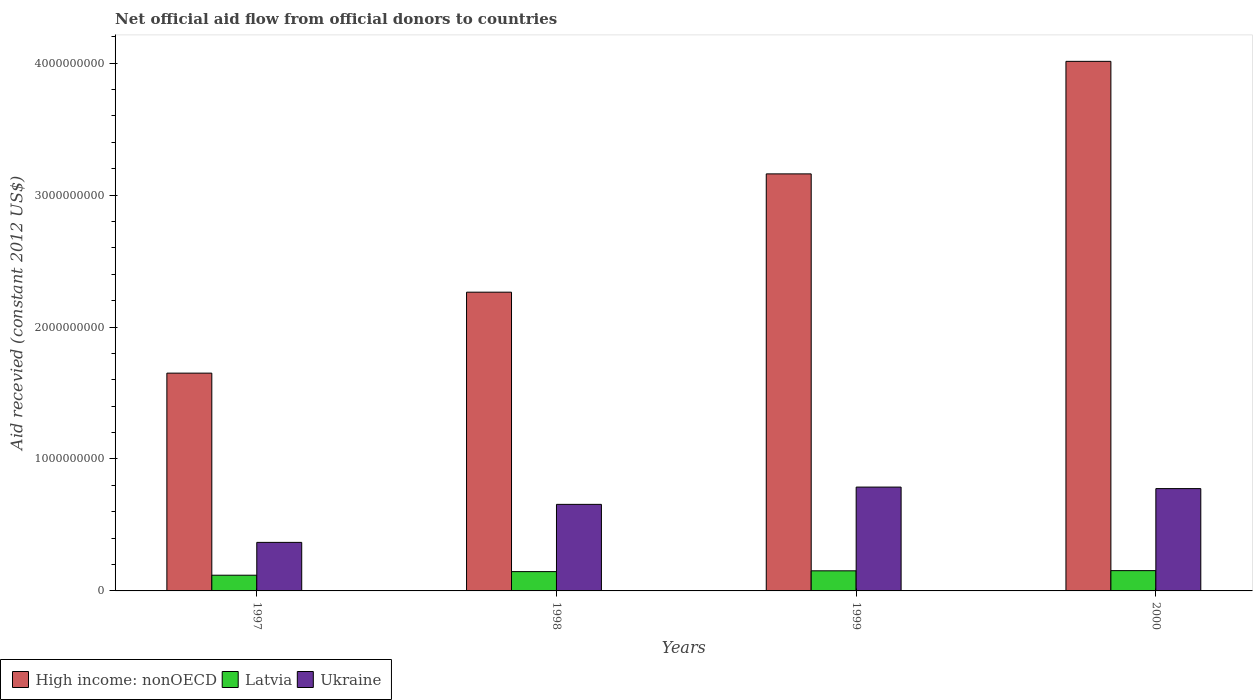How many bars are there on the 1st tick from the right?
Offer a very short reply. 3. In how many cases, is the number of bars for a given year not equal to the number of legend labels?
Keep it short and to the point. 0. What is the total aid received in High income: nonOECD in 1997?
Keep it short and to the point. 1.65e+09. Across all years, what is the maximum total aid received in Ukraine?
Your answer should be compact. 7.87e+08. Across all years, what is the minimum total aid received in High income: nonOECD?
Provide a succinct answer. 1.65e+09. In which year was the total aid received in Ukraine minimum?
Provide a short and direct response. 1997. What is the total total aid received in Latvia in the graph?
Your answer should be very brief. 5.72e+08. What is the difference between the total aid received in High income: nonOECD in 1997 and that in 2000?
Provide a succinct answer. -2.36e+09. What is the difference between the total aid received in High income: nonOECD in 1997 and the total aid received in Ukraine in 1999?
Your answer should be very brief. 8.64e+08. What is the average total aid received in Latvia per year?
Keep it short and to the point. 1.43e+08. In the year 1997, what is the difference between the total aid received in Latvia and total aid received in Ukraine?
Make the answer very short. -2.49e+08. What is the ratio of the total aid received in High income: nonOECD in 1998 to that in 1999?
Your answer should be compact. 0.72. Is the difference between the total aid received in Latvia in 1998 and 1999 greater than the difference between the total aid received in Ukraine in 1998 and 1999?
Your answer should be very brief. Yes. What is the difference between the highest and the second highest total aid received in Ukraine?
Provide a succinct answer. 1.14e+07. What is the difference between the highest and the lowest total aid received in Latvia?
Give a very brief answer. 3.48e+07. In how many years, is the total aid received in High income: nonOECD greater than the average total aid received in High income: nonOECD taken over all years?
Give a very brief answer. 2. What does the 2nd bar from the left in 2000 represents?
Keep it short and to the point. Latvia. What does the 3rd bar from the right in 1997 represents?
Offer a terse response. High income: nonOECD. Is it the case that in every year, the sum of the total aid received in Latvia and total aid received in High income: nonOECD is greater than the total aid received in Ukraine?
Give a very brief answer. Yes. How many bars are there?
Your response must be concise. 12. How many years are there in the graph?
Offer a terse response. 4. Are the values on the major ticks of Y-axis written in scientific E-notation?
Provide a short and direct response. No. Does the graph contain grids?
Your answer should be very brief. No. Where does the legend appear in the graph?
Offer a terse response. Bottom left. How many legend labels are there?
Give a very brief answer. 3. What is the title of the graph?
Ensure brevity in your answer.  Net official aid flow from official donors to countries. Does "Benin" appear as one of the legend labels in the graph?
Offer a very short reply. No. What is the label or title of the X-axis?
Make the answer very short. Years. What is the label or title of the Y-axis?
Make the answer very short. Aid recevied (constant 2012 US$). What is the Aid recevied (constant 2012 US$) of High income: nonOECD in 1997?
Offer a very short reply. 1.65e+09. What is the Aid recevied (constant 2012 US$) of Latvia in 1997?
Offer a terse response. 1.19e+08. What is the Aid recevied (constant 2012 US$) in Ukraine in 1997?
Keep it short and to the point. 3.68e+08. What is the Aid recevied (constant 2012 US$) in High income: nonOECD in 1998?
Your response must be concise. 2.26e+09. What is the Aid recevied (constant 2012 US$) of Latvia in 1998?
Offer a very short reply. 1.46e+08. What is the Aid recevied (constant 2012 US$) in Ukraine in 1998?
Ensure brevity in your answer.  6.56e+08. What is the Aid recevied (constant 2012 US$) in High income: nonOECD in 1999?
Provide a succinct answer. 3.16e+09. What is the Aid recevied (constant 2012 US$) of Latvia in 1999?
Give a very brief answer. 1.52e+08. What is the Aid recevied (constant 2012 US$) in Ukraine in 1999?
Your response must be concise. 7.87e+08. What is the Aid recevied (constant 2012 US$) of High income: nonOECD in 2000?
Keep it short and to the point. 4.01e+09. What is the Aid recevied (constant 2012 US$) in Latvia in 2000?
Make the answer very short. 1.54e+08. What is the Aid recevied (constant 2012 US$) in Ukraine in 2000?
Ensure brevity in your answer.  7.75e+08. Across all years, what is the maximum Aid recevied (constant 2012 US$) in High income: nonOECD?
Your answer should be very brief. 4.01e+09. Across all years, what is the maximum Aid recevied (constant 2012 US$) in Latvia?
Offer a terse response. 1.54e+08. Across all years, what is the maximum Aid recevied (constant 2012 US$) in Ukraine?
Make the answer very short. 7.87e+08. Across all years, what is the minimum Aid recevied (constant 2012 US$) of High income: nonOECD?
Provide a short and direct response. 1.65e+09. Across all years, what is the minimum Aid recevied (constant 2012 US$) of Latvia?
Your answer should be compact. 1.19e+08. Across all years, what is the minimum Aid recevied (constant 2012 US$) in Ukraine?
Your answer should be compact. 3.68e+08. What is the total Aid recevied (constant 2012 US$) in High income: nonOECD in the graph?
Give a very brief answer. 1.11e+1. What is the total Aid recevied (constant 2012 US$) of Latvia in the graph?
Offer a very short reply. 5.72e+08. What is the total Aid recevied (constant 2012 US$) in Ukraine in the graph?
Give a very brief answer. 2.59e+09. What is the difference between the Aid recevied (constant 2012 US$) of High income: nonOECD in 1997 and that in 1998?
Keep it short and to the point. -6.13e+08. What is the difference between the Aid recevied (constant 2012 US$) in Latvia in 1997 and that in 1998?
Your answer should be very brief. -2.73e+07. What is the difference between the Aid recevied (constant 2012 US$) in Ukraine in 1997 and that in 1998?
Keep it short and to the point. -2.88e+08. What is the difference between the Aid recevied (constant 2012 US$) in High income: nonOECD in 1997 and that in 1999?
Offer a terse response. -1.51e+09. What is the difference between the Aid recevied (constant 2012 US$) in Latvia in 1997 and that in 1999?
Your response must be concise. -3.33e+07. What is the difference between the Aid recevied (constant 2012 US$) of Ukraine in 1997 and that in 1999?
Your answer should be very brief. -4.19e+08. What is the difference between the Aid recevied (constant 2012 US$) of High income: nonOECD in 1997 and that in 2000?
Keep it short and to the point. -2.36e+09. What is the difference between the Aid recevied (constant 2012 US$) of Latvia in 1997 and that in 2000?
Ensure brevity in your answer.  -3.48e+07. What is the difference between the Aid recevied (constant 2012 US$) of Ukraine in 1997 and that in 2000?
Provide a succinct answer. -4.08e+08. What is the difference between the Aid recevied (constant 2012 US$) of High income: nonOECD in 1998 and that in 1999?
Give a very brief answer. -8.97e+08. What is the difference between the Aid recevied (constant 2012 US$) in Latvia in 1998 and that in 1999?
Your answer should be very brief. -5.96e+06. What is the difference between the Aid recevied (constant 2012 US$) of Ukraine in 1998 and that in 1999?
Keep it short and to the point. -1.31e+08. What is the difference between the Aid recevied (constant 2012 US$) in High income: nonOECD in 1998 and that in 2000?
Provide a succinct answer. -1.75e+09. What is the difference between the Aid recevied (constant 2012 US$) of Latvia in 1998 and that in 2000?
Provide a short and direct response. -7.46e+06. What is the difference between the Aid recevied (constant 2012 US$) in Ukraine in 1998 and that in 2000?
Keep it short and to the point. -1.19e+08. What is the difference between the Aid recevied (constant 2012 US$) in High income: nonOECD in 1999 and that in 2000?
Make the answer very short. -8.53e+08. What is the difference between the Aid recevied (constant 2012 US$) in Latvia in 1999 and that in 2000?
Your answer should be compact. -1.50e+06. What is the difference between the Aid recevied (constant 2012 US$) in Ukraine in 1999 and that in 2000?
Offer a very short reply. 1.14e+07. What is the difference between the Aid recevied (constant 2012 US$) of High income: nonOECD in 1997 and the Aid recevied (constant 2012 US$) of Latvia in 1998?
Your response must be concise. 1.50e+09. What is the difference between the Aid recevied (constant 2012 US$) of High income: nonOECD in 1997 and the Aid recevied (constant 2012 US$) of Ukraine in 1998?
Make the answer very short. 9.95e+08. What is the difference between the Aid recevied (constant 2012 US$) in Latvia in 1997 and the Aid recevied (constant 2012 US$) in Ukraine in 1998?
Provide a succinct answer. -5.37e+08. What is the difference between the Aid recevied (constant 2012 US$) of High income: nonOECD in 1997 and the Aid recevied (constant 2012 US$) of Latvia in 1999?
Offer a very short reply. 1.50e+09. What is the difference between the Aid recevied (constant 2012 US$) of High income: nonOECD in 1997 and the Aid recevied (constant 2012 US$) of Ukraine in 1999?
Ensure brevity in your answer.  8.64e+08. What is the difference between the Aid recevied (constant 2012 US$) in Latvia in 1997 and the Aid recevied (constant 2012 US$) in Ukraine in 1999?
Ensure brevity in your answer.  -6.68e+08. What is the difference between the Aid recevied (constant 2012 US$) in High income: nonOECD in 1997 and the Aid recevied (constant 2012 US$) in Latvia in 2000?
Make the answer very short. 1.50e+09. What is the difference between the Aid recevied (constant 2012 US$) in High income: nonOECD in 1997 and the Aid recevied (constant 2012 US$) in Ukraine in 2000?
Offer a terse response. 8.75e+08. What is the difference between the Aid recevied (constant 2012 US$) in Latvia in 1997 and the Aid recevied (constant 2012 US$) in Ukraine in 2000?
Keep it short and to the point. -6.56e+08. What is the difference between the Aid recevied (constant 2012 US$) of High income: nonOECD in 1998 and the Aid recevied (constant 2012 US$) of Latvia in 1999?
Your response must be concise. 2.11e+09. What is the difference between the Aid recevied (constant 2012 US$) of High income: nonOECD in 1998 and the Aid recevied (constant 2012 US$) of Ukraine in 1999?
Make the answer very short. 1.48e+09. What is the difference between the Aid recevied (constant 2012 US$) of Latvia in 1998 and the Aid recevied (constant 2012 US$) of Ukraine in 1999?
Offer a terse response. -6.41e+08. What is the difference between the Aid recevied (constant 2012 US$) of High income: nonOECD in 1998 and the Aid recevied (constant 2012 US$) of Latvia in 2000?
Ensure brevity in your answer.  2.11e+09. What is the difference between the Aid recevied (constant 2012 US$) in High income: nonOECD in 1998 and the Aid recevied (constant 2012 US$) in Ukraine in 2000?
Offer a terse response. 1.49e+09. What is the difference between the Aid recevied (constant 2012 US$) in Latvia in 1998 and the Aid recevied (constant 2012 US$) in Ukraine in 2000?
Make the answer very short. -6.29e+08. What is the difference between the Aid recevied (constant 2012 US$) of High income: nonOECD in 1999 and the Aid recevied (constant 2012 US$) of Latvia in 2000?
Your answer should be very brief. 3.01e+09. What is the difference between the Aid recevied (constant 2012 US$) of High income: nonOECD in 1999 and the Aid recevied (constant 2012 US$) of Ukraine in 2000?
Provide a short and direct response. 2.39e+09. What is the difference between the Aid recevied (constant 2012 US$) of Latvia in 1999 and the Aid recevied (constant 2012 US$) of Ukraine in 2000?
Your answer should be very brief. -6.23e+08. What is the average Aid recevied (constant 2012 US$) of High income: nonOECD per year?
Provide a succinct answer. 2.77e+09. What is the average Aid recevied (constant 2012 US$) of Latvia per year?
Offer a terse response. 1.43e+08. What is the average Aid recevied (constant 2012 US$) of Ukraine per year?
Make the answer very short. 6.47e+08. In the year 1997, what is the difference between the Aid recevied (constant 2012 US$) in High income: nonOECD and Aid recevied (constant 2012 US$) in Latvia?
Make the answer very short. 1.53e+09. In the year 1997, what is the difference between the Aid recevied (constant 2012 US$) in High income: nonOECD and Aid recevied (constant 2012 US$) in Ukraine?
Your answer should be very brief. 1.28e+09. In the year 1997, what is the difference between the Aid recevied (constant 2012 US$) in Latvia and Aid recevied (constant 2012 US$) in Ukraine?
Your response must be concise. -2.49e+08. In the year 1998, what is the difference between the Aid recevied (constant 2012 US$) in High income: nonOECD and Aid recevied (constant 2012 US$) in Latvia?
Offer a very short reply. 2.12e+09. In the year 1998, what is the difference between the Aid recevied (constant 2012 US$) of High income: nonOECD and Aid recevied (constant 2012 US$) of Ukraine?
Ensure brevity in your answer.  1.61e+09. In the year 1998, what is the difference between the Aid recevied (constant 2012 US$) in Latvia and Aid recevied (constant 2012 US$) in Ukraine?
Your answer should be very brief. -5.10e+08. In the year 1999, what is the difference between the Aid recevied (constant 2012 US$) of High income: nonOECD and Aid recevied (constant 2012 US$) of Latvia?
Your answer should be very brief. 3.01e+09. In the year 1999, what is the difference between the Aid recevied (constant 2012 US$) of High income: nonOECD and Aid recevied (constant 2012 US$) of Ukraine?
Your response must be concise. 2.37e+09. In the year 1999, what is the difference between the Aid recevied (constant 2012 US$) in Latvia and Aid recevied (constant 2012 US$) in Ukraine?
Make the answer very short. -6.35e+08. In the year 2000, what is the difference between the Aid recevied (constant 2012 US$) in High income: nonOECD and Aid recevied (constant 2012 US$) in Latvia?
Ensure brevity in your answer.  3.86e+09. In the year 2000, what is the difference between the Aid recevied (constant 2012 US$) in High income: nonOECD and Aid recevied (constant 2012 US$) in Ukraine?
Offer a terse response. 3.24e+09. In the year 2000, what is the difference between the Aid recevied (constant 2012 US$) in Latvia and Aid recevied (constant 2012 US$) in Ukraine?
Ensure brevity in your answer.  -6.22e+08. What is the ratio of the Aid recevied (constant 2012 US$) of High income: nonOECD in 1997 to that in 1998?
Make the answer very short. 0.73. What is the ratio of the Aid recevied (constant 2012 US$) in Latvia in 1997 to that in 1998?
Your answer should be compact. 0.81. What is the ratio of the Aid recevied (constant 2012 US$) of Ukraine in 1997 to that in 1998?
Provide a succinct answer. 0.56. What is the ratio of the Aid recevied (constant 2012 US$) of High income: nonOECD in 1997 to that in 1999?
Offer a terse response. 0.52. What is the ratio of the Aid recevied (constant 2012 US$) in Latvia in 1997 to that in 1999?
Provide a short and direct response. 0.78. What is the ratio of the Aid recevied (constant 2012 US$) in Ukraine in 1997 to that in 1999?
Keep it short and to the point. 0.47. What is the ratio of the Aid recevied (constant 2012 US$) of High income: nonOECD in 1997 to that in 2000?
Give a very brief answer. 0.41. What is the ratio of the Aid recevied (constant 2012 US$) of Latvia in 1997 to that in 2000?
Your answer should be very brief. 0.77. What is the ratio of the Aid recevied (constant 2012 US$) of Ukraine in 1997 to that in 2000?
Provide a short and direct response. 0.47. What is the ratio of the Aid recevied (constant 2012 US$) of High income: nonOECD in 1998 to that in 1999?
Your answer should be very brief. 0.72. What is the ratio of the Aid recevied (constant 2012 US$) of Latvia in 1998 to that in 1999?
Provide a succinct answer. 0.96. What is the ratio of the Aid recevied (constant 2012 US$) of Ukraine in 1998 to that in 1999?
Provide a succinct answer. 0.83. What is the ratio of the Aid recevied (constant 2012 US$) in High income: nonOECD in 1998 to that in 2000?
Provide a short and direct response. 0.56. What is the ratio of the Aid recevied (constant 2012 US$) in Latvia in 1998 to that in 2000?
Offer a terse response. 0.95. What is the ratio of the Aid recevied (constant 2012 US$) of Ukraine in 1998 to that in 2000?
Your response must be concise. 0.85. What is the ratio of the Aid recevied (constant 2012 US$) of High income: nonOECD in 1999 to that in 2000?
Your response must be concise. 0.79. What is the ratio of the Aid recevied (constant 2012 US$) in Latvia in 1999 to that in 2000?
Your response must be concise. 0.99. What is the ratio of the Aid recevied (constant 2012 US$) in Ukraine in 1999 to that in 2000?
Your response must be concise. 1.01. What is the difference between the highest and the second highest Aid recevied (constant 2012 US$) of High income: nonOECD?
Keep it short and to the point. 8.53e+08. What is the difference between the highest and the second highest Aid recevied (constant 2012 US$) of Latvia?
Your response must be concise. 1.50e+06. What is the difference between the highest and the second highest Aid recevied (constant 2012 US$) of Ukraine?
Give a very brief answer. 1.14e+07. What is the difference between the highest and the lowest Aid recevied (constant 2012 US$) in High income: nonOECD?
Keep it short and to the point. 2.36e+09. What is the difference between the highest and the lowest Aid recevied (constant 2012 US$) in Latvia?
Make the answer very short. 3.48e+07. What is the difference between the highest and the lowest Aid recevied (constant 2012 US$) in Ukraine?
Keep it short and to the point. 4.19e+08. 